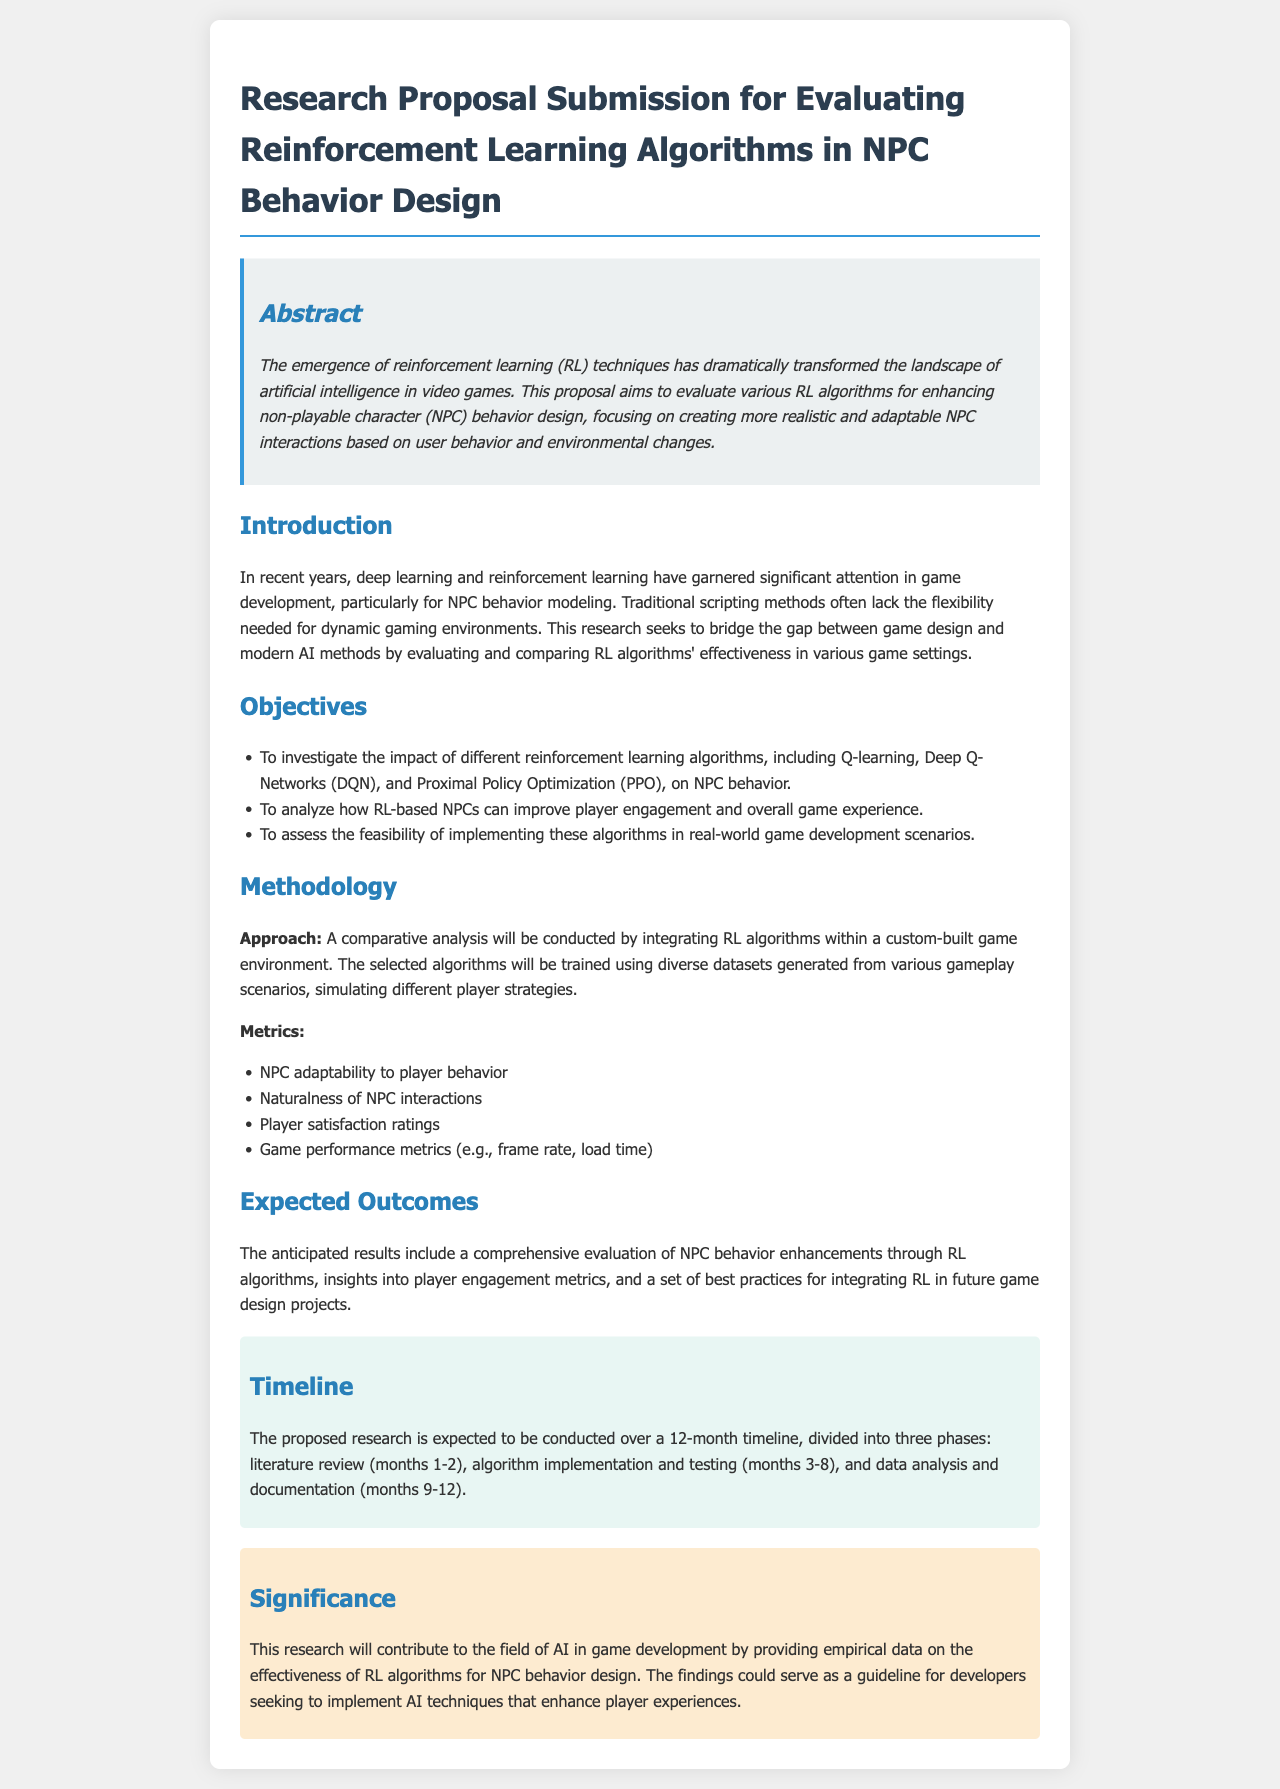What is the main focus of the research proposal? The proposal focuses on evaluating various RL algorithms for enhancing non-playable character (NPC) behavior design.
Answer: enhancing NPC behavior design What are the three RL algorithms mentioned in the proposal? The proposal specifically mentions Q-learning, Deep Q-Networks (DQN), and Proximal Policy Optimization (PPO).
Answer: Q-learning, Deep Q-Networks (DQN), Proximal Policy Optimization (PPO) How many months is the proposed research timeline? The document states that the proposed research will be conducted over a 12-month timeline.
Answer: 12 months What is one of the metrics for assessing NPC behavior? One of the metrics listed for assessing NPC behavior is NPC adaptability to player behavior.
Answer: NPC adaptability to player behavior What is the expected outcome related to player engagement? The anticipated result includes insights into player engagement metrics.
Answer: insights into player engagement metrics What phase comes first in the research timeline? The first phase of the research timeline is the literature review.
Answer: literature review How does the proposal suggest measuring player satisfaction? Player satisfaction will be measured through player satisfaction ratings.
Answer: player satisfaction ratings What type of study does the proposal aim to conduct? The proposal aims to conduct a comparative analysis.
Answer: comparative analysis 